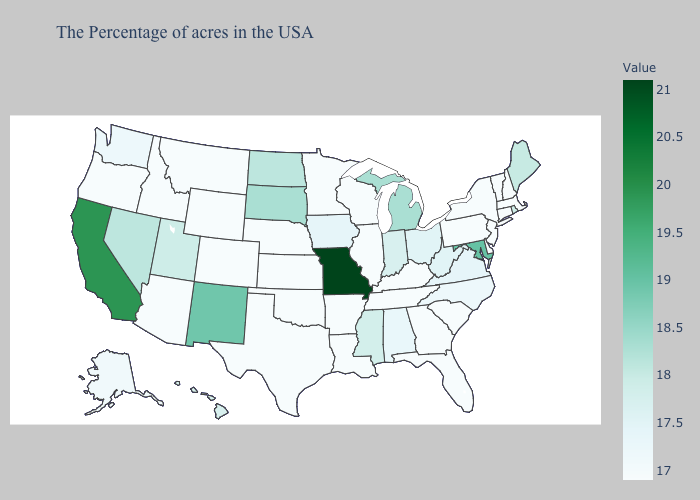Does Nebraska have a higher value than Iowa?
Quick response, please. No. Does Missouri have the lowest value in the MidWest?
Write a very short answer. No. Which states have the lowest value in the MidWest?
Keep it brief. Wisconsin, Illinois, Minnesota, Kansas, Nebraska. Does Indiana have a lower value than South Dakota?
Concise answer only. Yes. Does New York have a lower value than Ohio?
Keep it brief. Yes. Does Missouri have the highest value in the MidWest?
Be succinct. Yes. Which states hav the highest value in the West?
Give a very brief answer. California. Which states have the lowest value in the USA?
Quick response, please. Massachusetts, New Hampshire, Vermont, Connecticut, New York, New Jersey, Delaware, Pennsylvania, South Carolina, Florida, Georgia, Kentucky, Tennessee, Wisconsin, Illinois, Louisiana, Arkansas, Minnesota, Kansas, Nebraska, Oklahoma, Texas, Wyoming, Colorado, Montana, Arizona, Idaho, Oregon. 